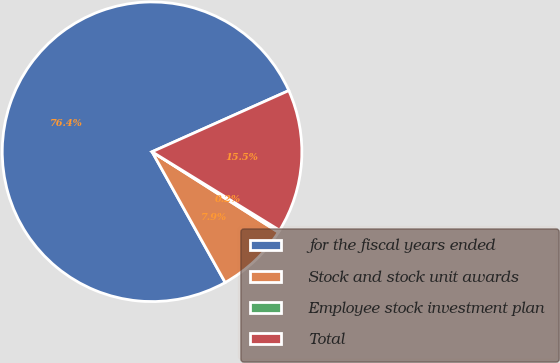Convert chart. <chart><loc_0><loc_0><loc_500><loc_500><pie_chart><fcel>for the fiscal years ended<fcel>Stock and stock unit awards<fcel>Employee stock investment plan<fcel>Total<nl><fcel>76.43%<fcel>7.86%<fcel>0.24%<fcel>15.48%<nl></chart> 